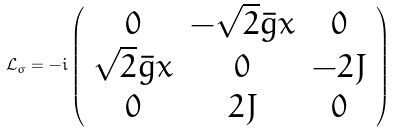Convert formula to latex. <formula><loc_0><loc_0><loc_500><loc_500>\mathcal { L } _ { \sigma } = - i \left ( \begin{array} { c c c } 0 & - \sqrt { 2 } \bar { g } x & 0 \\ \sqrt { 2 } \bar { g } x & 0 & - 2 J \\ 0 & 2 J & 0 \end{array} \right )</formula> 